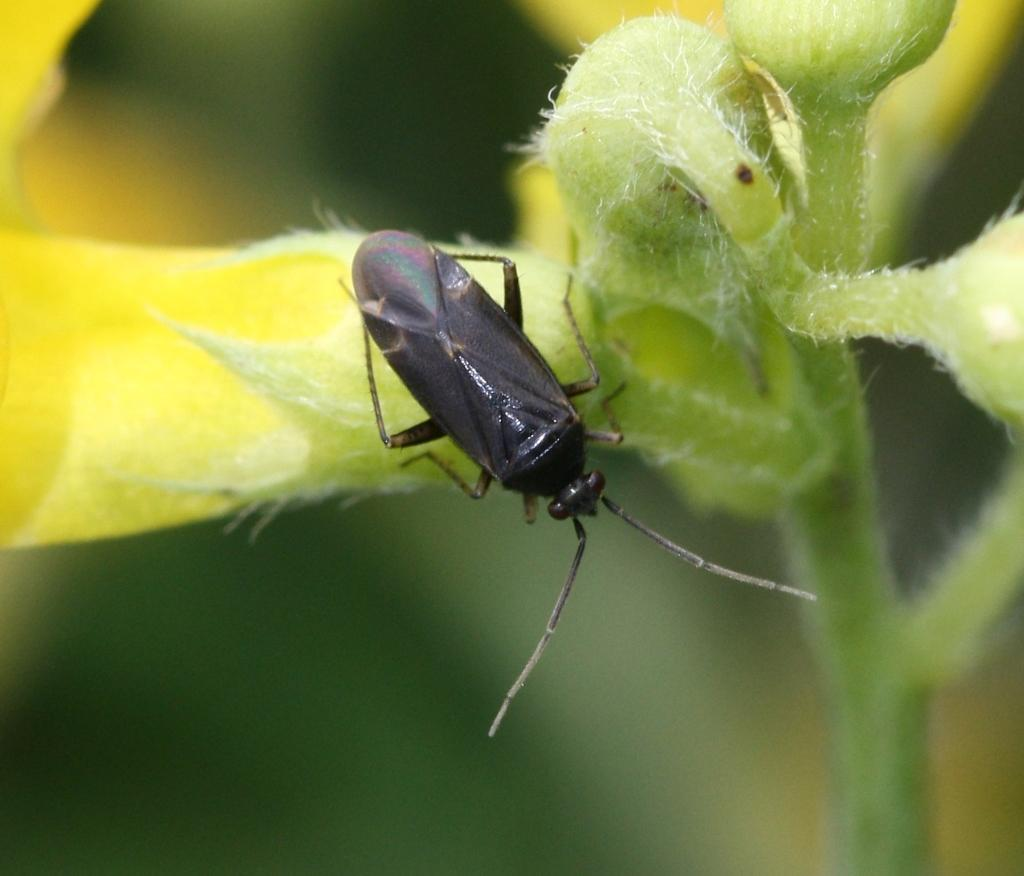What is present in the image? There is a plant and a black color insect in the image. Can you describe the insect in the image? The insect is black in color. What can be observed about the background of the image? The background of the image is blurred. What type of letters can be seen on the plant in the image? There are no letters present on the plant in the image. Where is the store located in the image? There is no store present in the image. 